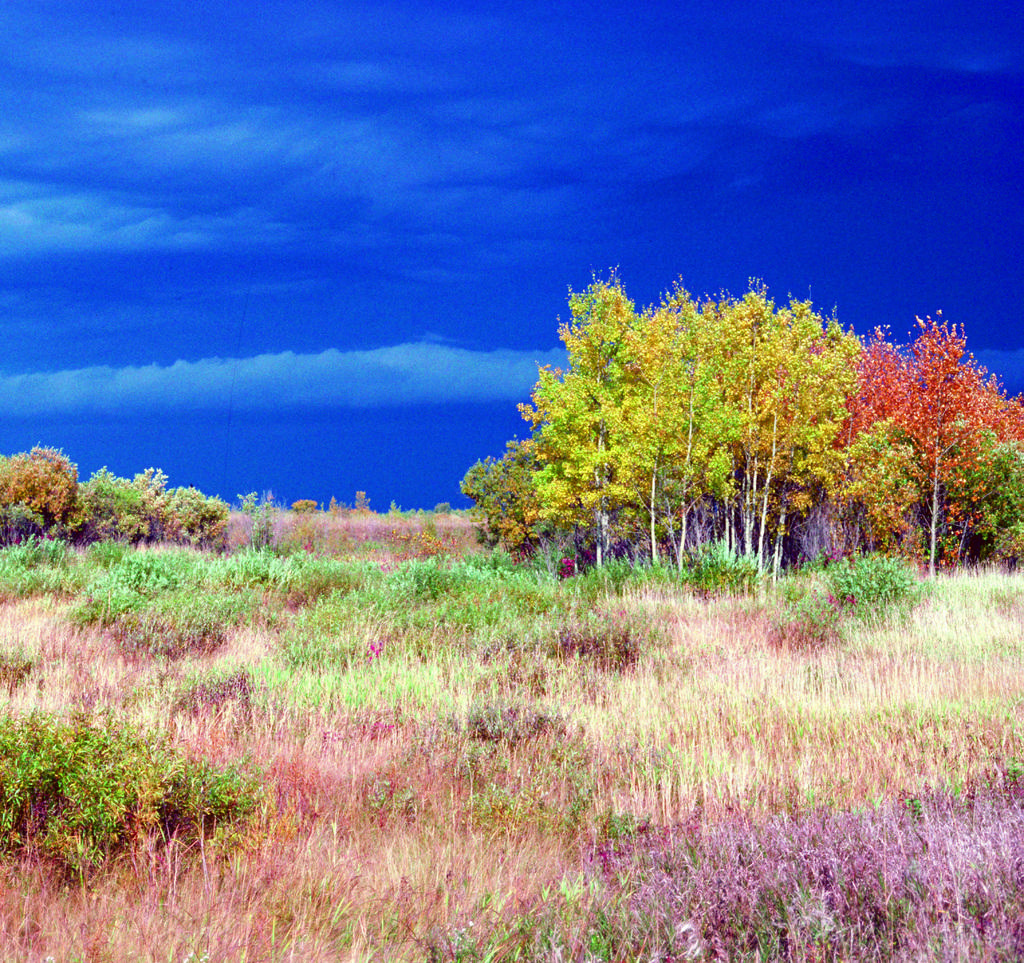What type of vegetation can be seen in the image? There are many trees, plants, and grass in the image. What is visible at the top of the image? The sky is visible at the top of the image. What can be seen in the sky? Clouds are present in the sky. What sign is the minister holding in the image? There is no sign or minister present in the image. 